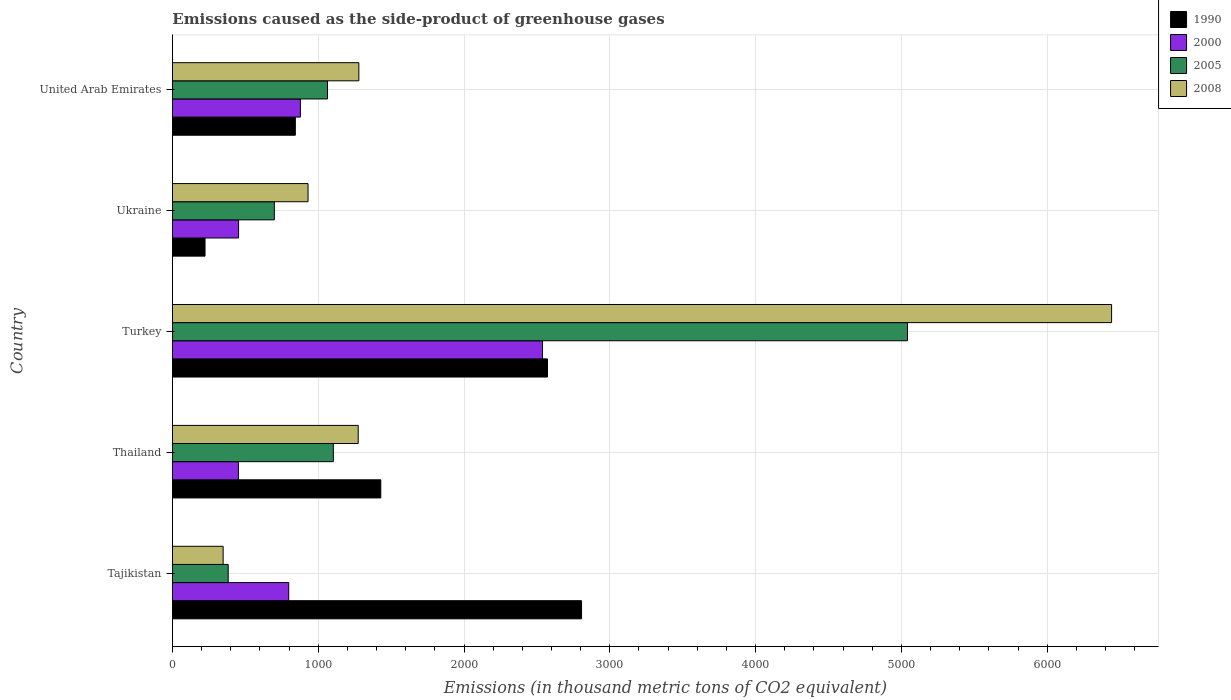How many different coloured bars are there?
Keep it short and to the point. 4. How many groups of bars are there?
Offer a terse response. 5. Are the number of bars per tick equal to the number of legend labels?
Provide a short and direct response. Yes. Are the number of bars on each tick of the Y-axis equal?
Provide a succinct answer. Yes. How many bars are there on the 3rd tick from the top?
Offer a very short reply. 4. How many bars are there on the 2nd tick from the bottom?
Make the answer very short. 4. What is the label of the 2nd group of bars from the top?
Give a very brief answer. Ukraine. What is the emissions caused as the side-product of greenhouse gases in 2005 in Turkey?
Your answer should be very brief. 5041.3. Across all countries, what is the maximum emissions caused as the side-product of greenhouse gases in 2008?
Make the answer very short. 6441. Across all countries, what is the minimum emissions caused as the side-product of greenhouse gases in 2005?
Provide a short and direct response. 383. In which country was the emissions caused as the side-product of greenhouse gases in 2008 maximum?
Give a very brief answer. Turkey. In which country was the emissions caused as the side-product of greenhouse gases in 1990 minimum?
Ensure brevity in your answer.  Ukraine. What is the total emissions caused as the side-product of greenhouse gases in 2000 in the graph?
Provide a short and direct response. 5121.9. What is the difference between the emissions caused as the side-product of greenhouse gases in 2005 in Ukraine and that in United Arab Emirates?
Offer a terse response. -364.8. What is the difference between the emissions caused as the side-product of greenhouse gases in 2008 in Tajikistan and the emissions caused as the side-product of greenhouse gases in 1990 in United Arab Emirates?
Ensure brevity in your answer.  -495.1. What is the average emissions caused as the side-product of greenhouse gases in 2005 per country?
Provide a short and direct response. 1658.32. What is the difference between the emissions caused as the side-product of greenhouse gases in 2000 and emissions caused as the side-product of greenhouse gases in 2005 in Thailand?
Ensure brevity in your answer.  -650.8. What is the ratio of the emissions caused as the side-product of greenhouse gases in 2000 in Thailand to that in Turkey?
Your answer should be compact. 0.18. Is the emissions caused as the side-product of greenhouse gases in 1990 in Turkey less than that in Ukraine?
Provide a short and direct response. No. Is the difference between the emissions caused as the side-product of greenhouse gases in 2000 in Thailand and United Arab Emirates greater than the difference between the emissions caused as the side-product of greenhouse gases in 2005 in Thailand and United Arab Emirates?
Provide a succinct answer. No. What is the difference between the highest and the second highest emissions caused as the side-product of greenhouse gases in 2005?
Give a very brief answer. 3937.4. What is the difference between the highest and the lowest emissions caused as the side-product of greenhouse gases in 2000?
Your response must be concise. 2085.4. Is the sum of the emissions caused as the side-product of greenhouse gases in 2000 in Turkey and Ukraine greater than the maximum emissions caused as the side-product of greenhouse gases in 2005 across all countries?
Your response must be concise. No. What does the 4th bar from the bottom in Thailand represents?
Give a very brief answer. 2008. Is it the case that in every country, the sum of the emissions caused as the side-product of greenhouse gases in 2005 and emissions caused as the side-product of greenhouse gases in 2008 is greater than the emissions caused as the side-product of greenhouse gases in 2000?
Provide a short and direct response. No. How many countries are there in the graph?
Your answer should be compact. 5. Are the values on the major ticks of X-axis written in scientific E-notation?
Give a very brief answer. No. Where does the legend appear in the graph?
Offer a terse response. Top right. How many legend labels are there?
Keep it short and to the point. 4. How are the legend labels stacked?
Offer a terse response. Vertical. What is the title of the graph?
Your answer should be very brief. Emissions caused as the side-product of greenhouse gases. Does "1963" appear as one of the legend labels in the graph?
Offer a very short reply. No. What is the label or title of the X-axis?
Keep it short and to the point. Emissions (in thousand metric tons of CO2 equivalent). What is the Emissions (in thousand metric tons of CO2 equivalent) of 1990 in Tajikistan?
Keep it short and to the point. 2806.1. What is the Emissions (in thousand metric tons of CO2 equivalent) in 2000 in Tajikistan?
Your response must be concise. 798. What is the Emissions (in thousand metric tons of CO2 equivalent) in 2005 in Tajikistan?
Your answer should be very brief. 383. What is the Emissions (in thousand metric tons of CO2 equivalent) in 2008 in Tajikistan?
Keep it short and to the point. 348.3. What is the Emissions (in thousand metric tons of CO2 equivalent) of 1990 in Thailand?
Keep it short and to the point. 1429.5. What is the Emissions (in thousand metric tons of CO2 equivalent) in 2000 in Thailand?
Your answer should be compact. 453.1. What is the Emissions (in thousand metric tons of CO2 equivalent) of 2005 in Thailand?
Provide a succinct answer. 1103.9. What is the Emissions (in thousand metric tons of CO2 equivalent) of 2008 in Thailand?
Offer a terse response. 1274.5. What is the Emissions (in thousand metric tons of CO2 equivalent) in 1990 in Turkey?
Your answer should be compact. 2572.7. What is the Emissions (in thousand metric tons of CO2 equivalent) in 2000 in Turkey?
Provide a succinct answer. 2538.5. What is the Emissions (in thousand metric tons of CO2 equivalent) in 2005 in Turkey?
Provide a short and direct response. 5041.3. What is the Emissions (in thousand metric tons of CO2 equivalent) in 2008 in Turkey?
Offer a very short reply. 6441. What is the Emissions (in thousand metric tons of CO2 equivalent) of 1990 in Ukraine?
Provide a succinct answer. 224.1. What is the Emissions (in thousand metric tons of CO2 equivalent) in 2000 in Ukraine?
Your response must be concise. 454.2. What is the Emissions (in thousand metric tons of CO2 equivalent) of 2005 in Ukraine?
Your answer should be compact. 699.3. What is the Emissions (in thousand metric tons of CO2 equivalent) of 2008 in Ukraine?
Your answer should be very brief. 930.6. What is the Emissions (in thousand metric tons of CO2 equivalent) in 1990 in United Arab Emirates?
Provide a succinct answer. 843.4. What is the Emissions (in thousand metric tons of CO2 equivalent) of 2000 in United Arab Emirates?
Offer a very short reply. 878.1. What is the Emissions (in thousand metric tons of CO2 equivalent) of 2005 in United Arab Emirates?
Make the answer very short. 1064.1. What is the Emissions (in thousand metric tons of CO2 equivalent) in 2008 in United Arab Emirates?
Ensure brevity in your answer.  1279. Across all countries, what is the maximum Emissions (in thousand metric tons of CO2 equivalent) of 1990?
Your response must be concise. 2806.1. Across all countries, what is the maximum Emissions (in thousand metric tons of CO2 equivalent) of 2000?
Your response must be concise. 2538.5. Across all countries, what is the maximum Emissions (in thousand metric tons of CO2 equivalent) of 2005?
Provide a short and direct response. 5041.3. Across all countries, what is the maximum Emissions (in thousand metric tons of CO2 equivalent) of 2008?
Give a very brief answer. 6441. Across all countries, what is the minimum Emissions (in thousand metric tons of CO2 equivalent) of 1990?
Make the answer very short. 224.1. Across all countries, what is the minimum Emissions (in thousand metric tons of CO2 equivalent) in 2000?
Provide a succinct answer. 453.1. Across all countries, what is the minimum Emissions (in thousand metric tons of CO2 equivalent) in 2005?
Your answer should be compact. 383. Across all countries, what is the minimum Emissions (in thousand metric tons of CO2 equivalent) of 2008?
Give a very brief answer. 348.3. What is the total Emissions (in thousand metric tons of CO2 equivalent) in 1990 in the graph?
Provide a succinct answer. 7875.8. What is the total Emissions (in thousand metric tons of CO2 equivalent) in 2000 in the graph?
Provide a succinct answer. 5121.9. What is the total Emissions (in thousand metric tons of CO2 equivalent) of 2005 in the graph?
Provide a short and direct response. 8291.6. What is the total Emissions (in thousand metric tons of CO2 equivalent) in 2008 in the graph?
Offer a very short reply. 1.03e+04. What is the difference between the Emissions (in thousand metric tons of CO2 equivalent) of 1990 in Tajikistan and that in Thailand?
Keep it short and to the point. 1376.6. What is the difference between the Emissions (in thousand metric tons of CO2 equivalent) in 2000 in Tajikistan and that in Thailand?
Offer a very short reply. 344.9. What is the difference between the Emissions (in thousand metric tons of CO2 equivalent) in 2005 in Tajikistan and that in Thailand?
Offer a very short reply. -720.9. What is the difference between the Emissions (in thousand metric tons of CO2 equivalent) in 2008 in Tajikistan and that in Thailand?
Your answer should be compact. -926.2. What is the difference between the Emissions (in thousand metric tons of CO2 equivalent) of 1990 in Tajikistan and that in Turkey?
Provide a short and direct response. 233.4. What is the difference between the Emissions (in thousand metric tons of CO2 equivalent) of 2000 in Tajikistan and that in Turkey?
Ensure brevity in your answer.  -1740.5. What is the difference between the Emissions (in thousand metric tons of CO2 equivalent) in 2005 in Tajikistan and that in Turkey?
Give a very brief answer. -4658.3. What is the difference between the Emissions (in thousand metric tons of CO2 equivalent) in 2008 in Tajikistan and that in Turkey?
Offer a terse response. -6092.7. What is the difference between the Emissions (in thousand metric tons of CO2 equivalent) in 1990 in Tajikistan and that in Ukraine?
Your answer should be compact. 2582. What is the difference between the Emissions (in thousand metric tons of CO2 equivalent) of 2000 in Tajikistan and that in Ukraine?
Offer a terse response. 343.8. What is the difference between the Emissions (in thousand metric tons of CO2 equivalent) of 2005 in Tajikistan and that in Ukraine?
Provide a succinct answer. -316.3. What is the difference between the Emissions (in thousand metric tons of CO2 equivalent) of 2008 in Tajikistan and that in Ukraine?
Your response must be concise. -582.3. What is the difference between the Emissions (in thousand metric tons of CO2 equivalent) of 1990 in Tajikistan and that in United Arab Emirates?
Keep it short and to the point. 1962.7. What is the difference between the Emissions (in thousand metric tons of CO2 equivalent) in 2000 in Tajikistan and that in United Arab Emirates?
Offer a very short reply. -80.1. What is the difference between the Emissions (in thousand metric tons of CO2 equivalent) in 2005 in Tajikistan and that in United Arab Emirates?
Provide a short and direct response. -681.1. What is the difference between the Emissions (in thousand metric tons of CO2 equivalent) of 2008 in Tajikistan and that in United Arab Emirates?
Make the answer very short. -930.7. What is the difference between the Emissions (in thousand metric tons of CO2 equivalent) in 1990 in Thailand and that in Turkey?
Provide a short and direct response. -1143.2. What is the difference between the Emissions (in thousand metric tons of CO2 equivalent) of 2000 in Thailand and that in Turkey?
Make the answer very short. -2085.4. What is the difference between the Emissions (in thousand metric tons of CO2 equivalent) of 2005 in Thailand and that in Turkey?
Offer a terse response. -3937.4. What is the difference between the Emissions (in thousand metric tons of CO2 equivalent) of 2008 in Thailand and that in Turkey?
Offer a very short reply. -5166.5. What is the difference between the Emissions (in thousand metric tons of CO2 equivalent) in 1990 in Thailand and that in Ukraine?
Provide a succinct answer. 1205.4. What is the difference between the Emissions (in thousand metric tons of CO2 equivalent) of 2005 in Thailand and that in Ukraine?
Provide a short and direct response. 404.6. What is the difference between the Emissions (in thousand metric tons of CO2 equivalent) in 2008 in Thailand and that in Ukraine?
Give a very brief answer. 343.9. What is the difference between the Emissions (in thousand metric tons of CO2 equivalent) in 1990 in Thailand and that in United Arab Emirates?
Your answer should be very brief. 586.1. What is the difference between the Emissions (in thousand metric tons of CO2 equivalent) of 2000 in Thailand and that in United Arab Emirates?
Offer a terse response. -425. What is the difference between the Emissions (in thousand metric tons of CO2 equivalent) of 2005 in Thailand and that in United Arab Emirates?
Your response must be concise. 39.8. What is the difference between the Emissions (in thousand metric tons of CO2 equivalent) of 2008 in Thailand and that in United Arab Emirates?
Your answer should be compact. -4.5. What is the difference between the Emissions (in thousand metric tons of CO2 equivalent) in 1990 in Turkey and that in Ukraine?
Ensure brevity in your answer.  2348.6. What is the difference between the Emissions (in thousand metric tons of CO2 equivalent) of 2000 in Turkey and that in Ukraine?
Your response must be concise. 2084.3. What is the difference between the Emissions (in thousand metric tons of CO2 equivalent) of 2005 in Turkey and that in Ukraine?
Your response must be concise. 4342. What is the difference between the Emissions (in thousand metric tons of CO2 equivalent) in 2008 in Turkey and that in Ukraine?
Provide a succinct answer. 5510.4. What is the difference between the Emissions (in thousand metric tons of CO2 equivalent) of 1990 in Turkey and that in United Arab Emirates?
Keep it short and to the point. 1729.3. What is the difference between the Emissions (in thousand metric tons of CO2 equivalent) of 2000 in Turkey and that in United Arab Emirates?
Give a very brief answer. 1660.4. What is the difference between the Emissions (in thousand metric tons of CO2 equivalent) in 2005 in Turkey and that in United Arab Emirates?
Your answer should be compact. 3977.2. What is the difference between the Emissions (in thousand metric tons of CO2 equivalent) in 2008 in Turkey and that in United Arab Emirates?
Make the answer very short. 5162. What is the difference between the Emissions (in thousand metric tons of CO2 equivalent) of 1990 in Ukraine and that in United Arab Emirates?
Provide a succinct answer. -619.3. What is the difference between the Emissions (in thousand metric tons of CO2 equivalent) of 2000 in Ukraine and that in United Arab Emirates?
Provide a short and direct response. -423.9. What is the difference between the Emissions (in thousand metric tons of CO2 equivalent) of 2005 in Ukraine and that in United Arab Emirates?
Provide a succinct answer. -364.8. What is the difference between the Emissions (in thousand metric tons of CO2 equivalent) in 2008 in Ukraine and that in United Arab Emirates?
Provide a short and direct response. -348.4. What is the difference between the Emissions (in thousand metric tons of CO2 equivalent) in 1990 in Tajikistan and the Emissions (in thousand metric tons of CO2 equivalent) in 2000 in Thailand?
Ensure brevity in your answer.  2353. What is the difference between the Emissions (in thousand metric tons of CO2 equivalent) of 1990 in Tajikistan and the Emissions (in thousand metric tons of CO2 equivalent) of 2005 in Thailand?
Provide a succinct answer. 1702.2. What is the difference between the Emissions (in thousand metric tons of CO2 equivalent) of 1990 in Tajikistan and the Emissions (in thousand metric tons of CO2 equivalent) of 2008 in Thailand?
Your response must be concise. 1531.6. What is the difference between the Emissions (in thousand metric tons of CO2 equivalent) of 2000 in Tajikistan and the Emissions (in thousand metric tons of CO2 equivalent) of 2005 in Thailand?
Your answer should be very brief. -305.9. What is the difference between the Emissions (in thousand metric tons of CO2 equivalent) in 2000 in Tajikistan and the Emissions (in thousand metric tons of CO2 equivalent) in 2008 in Thailand?
Offer a terse response. -476.5. What is the difference between the Emissions (in thousand metric tons of CO2 equivalent) of 2005 in Tajikistan and the Emissions (in thousand metric tons of CO2 equivalent) of 2008 in Thailand?
Offer a very short reply. -891.5. What is the difference between the Emissions (in thousand metric tons of CO2 equivalent) of 1990 in Tajikistan and the Emissions (in thousand metric tons of CO2 equivalent) of 2000 in Turkey?
Offer a terse response. 267.6. What is the difference between the Emissions (in thousand metric tons of CO2 equivalent) of 1990 in Tajikistan and the Emissions (in thousand metric tons of CO2 equivalent) of 2005 in Turkey?
Your answer should be compact. -2235.2. What is the difference between the Emissions (in thousand metric tons of CO2 equivalent) of 1990 in Tajikistan and the Emissions (in thousand metric tons of CO2 equivalent) of 2008 in Turkey?
Offer a very short reply. -3634.9. What is the difference between the Emissions (in thousand metric tons of CO2 equivalent) of 2000 in Tajikistan and the Emissions (in thousand metric tons of CO2 equivalent) of 2005 in Turkey?
Offer a terse response. -4243.3. What is the difference between the Emissions (in thousand metric tons of CO2 equivalent) in 2000 in Tajikistan and the Emissions (in thousand metric tons of CO2 equivalent) in 2008 in Turkey?
Your response must be concise. -5643. What is the difference between the Emissions (in thousand metric tons of CO2 equivalent) in 2005 in Tajikistan and the Emissions (in thousand metric tons of CO2 equivalent) in 2008 in Turkey?
Give a very brief answer. -6058. What is the difference between the Emissions (in thousand metric tons of CO2 equivalent) in 1990 in Tajikistan and the Emissions (in thousand metric tons of CO2 equivalent) in 2000 in Ukraine?
Your response must be concise. 2351.9. What is the difference between the Emissions (in thousand metric tons of CO2 equivalent) of 1990 in Tajikistan and the Emissions (in thousand metric tons of CO2 equivalent) of 2005 in Ukraine?
Keep it short and to the point. 2106.8. What is the difference between the Emissions (in thousand metric tons of CO2 equivalent) of 1990 in Tajikistan and the Emissions (in thousand metric tons of CO2 equivalent) of 2008 in Ukraine?
Give a very brief answer. 1875.5. What is the difference between the Emissions (in thousand metric tons of CO2 equivalent) of 2000 in Tajikistan and the Emissions (in thousand metric tons of CO2 equivalent) of 2005 in Ukraine?
Offer a terse response. 98.7. What is the difference between the Emissions (in thousand metric tons of CO2 equivalent) of 2000 in Tajikistan and the Emissions (in thousand metric tons of CO2 equivalent) of 2008 in Ukraine?
Provide a succinct answer. -132.6. What is the difference between the Emissions (in thousand metric tons of CO2 equivalent) of 2005 in Tajikistan and the Emissions (in thousand metric tons of CO2 equivalent) of 2008 in Ukraine?
Your answer should be compact. -547.6. What is the difference between the Emissions (in thousand metric tons of CO2 equivalent) in 1990 in Tajikistan and the Emissions (in thousand metric tons of CO2 equivalent) in 2000 in United Arab Emirates?
Give a very brief answer. 1928. What is the difference between the Emissions (in thousand metric tons of CO2 equivalent) in 1990 in Tajikistan and the Emissions (in thousand metric tons of CO2 equivalent) in 2005 in United Arab Emirates?
Provide a succinct answer. 1742. What is the difference between the Emissions (in thousand metric tons of CO2 equivalent) of 1990 in Tajikistan and the Emissions (in thousand metric tons of CO2 equivalent) of 2008 in United Arab Emirates?
Make the answer very short. 1527.1. What is the difference between the Emissions (in thousand metric tons of CO2 equivalent) in 2000 in Tajikistan and the Emissions (in thousand metric tons of CO2 equivalent) in 2005 in United Arab Emirates?
Your answer should be compact. -266.1. What is the difference between the Emissions (in thousand metric tons of CO2 equivalent) of 2000 in Tajikistan and the Emissions (in thousand metric tons of CO2 equivalent) of 2008 in United Arab Emirates?
Your response must be concise. -481. What is the difference between the Emissions (in thousand metric tons of CO2 equivalent) of 2005 in Tajikistan and the Emissions (in thousand metric tons of CO2 equivalent) of 2008 in United Arab Emirates?
Keep it short and to the point. -896. What is the difference between the Emissions (in thousand metric tons of CO2 equivalent) in 1990 in Thailand and the Emissions (in thousand metric tons of CO2 equivalent) in 2000 in Turkey?
Provide a short and direct response. -1109. What is the difference between the Emissions (in thousand metric tons of CO2 equivalent) in 1990 in Thailand and the Emissions (in thousand metric tons of CO2 equivalent) in 2005 in Turkey?
Offer a very short reply. -3611.8. What is the difference between the Emissions (in thousand metric tons of CO2 equivalent) in 1990 in Thailand and the Emissions (in thousand metric tons of CO2 equivalent) in 2008 in Turkey?
Provide a succinct answer. -5011.5. What is the difference between the Emissions (in thousand metric tons of CO2 equivalent) in 2000 in Thailand and the Emissions (in thousand metric tons of CO2 equivalent) in 2005 in Turkey?
Your answer should be compact. -4588.2. What is the difference between the Emissions (in thousand metric tons of CO2 equivalent) of 2000 in Thailand and the Emissions (in thousand metric tons of CO2 equivalent) of 2008 in Turkey?
Your answer should be very brief. -5987.9. What is the difference between the Emissions (in thousand metric tons of CO2 equivalent) in 2005 in Thailand and the Emissions (in thousand metric tons of CO2 equivalent) in 2008 in Turkey?
Your answer should be compact. -5337.1. What is the difference between the Emissions (in thousand metric tons of CO2 equivalent) of 1990 in Thailand and the Emissions (in thousand metric tons of CO2 equivalent) of 2000 in Ukraine?
Make the answer very short. 975.3. What is the difference between the Emissions (in thousand metric tons of CO2 equivalent) of 1990 in Thailand and the Emissions (in thousand metric tons of CO2 equivalent) of 2005 in Ukraine?
Ensure brevity in your answer.  730.2. What is the difference between the Emissions (in thousand metric tons of CO2 equivalent) of 1990 in Thailand and the Emissions (in thousand metric tons of CO2 equivalent) of 2008 in Ukraine?
Your response must be concise. 498.9. What is the difference between the Emissions (in thousand metric tons of CO2 equivalent) in 2000 in Thailand and the Emissions (in thousand metric tons of CO2 equivalent) in 2005 in Ukraine?
Your answer should be compact. -246.2. What is the difference between the Emissions (in thousand metric tons of CO2 equivalent) of 2000 in Thailand and the Emissions (in thousand metric tons of CO2 equivalent) of 2008 in Ukraine?
Offer a very short reply. -477.5. What is the difference between the Emissions (in thousand metric tons of CO2 equivalent) in 2005 in Thailand and the Emissions (in thousand metric tons of CO2 equivalent) in 2008 in Ukraine?
Make the answer very short. 173.3. What is the difference between the Emissions (in thousand metric tons of CO2 equivalent) of 1990 in Thailand and the Emissions (in thousand metric tons of CO2 equivalent) of 2000 in United Arab Emirates?
Give a very brief answer. 551.4. What is the difference between the Emissions (in thousand metric tons of CO2 equivalent) of 1990 in Thailand and the Emissions (in thousand metric tons of CO2 equivalent) of 2005 in United Arab Emirates?
Your answer should be very brief. 365.4. What is the difference between the Emissions (in thousand metric tons of CO2 equivalent) of 1990 in Thailand and the Emissions (in thousand metric tons of CO2 equivalent) of 2008 in United Arab Emirates?
Give a very brief answer. 150.5. What is the difference between the Emissions (in thousand metric tons of CO2 equivalent) of 2000 in Thailand and the Emissions (in thousand metric tons of CO2 equivalent) of 2005 in United Arab Emirates?
Make the answer very short. -611. What is the difference between the Emissions (in thousand metric tons of CO2 equivalent) of 2000 in Thailand and the Emissions (in thousand metric tons of CO2 equivalent) of 2008 in United Arab Emirates?
Provide a succinct answer. -825.9. What is the difference between the Emissions (in thousand metric tons of CO2 equivalent) in 2005 in Thailand and the Emissions (in thousand metric tons of CO2 equivalent) in 2008 in United Arab Emirates?
Your answer should be very brief. -175.1. What is the difference between the Emissions (in thousand metric tons of CO2 equivalent) in 1990 in Turkey and the Emissions (in thousand metric tons of CO2 equivalent) in 2000 in Ukraine?
Ensure brevity in your answer.  2118.5. What is the difference between the Emissions (in thousand metric tons of CO2 equivalent) in 1990 in Turkey and the Emissions (in thousand metric tons of CO2 equivalent) in 2005 in Ukraine?
Provide a succinct answer. 1873.4. What is the difference between the Emissions (in thousand metric tons of CO2 equivalent) of 1990 in Turkey and the Emissions (in thousand metric tons of CO2 equivalent) of 2008 in Ukraine?
Provide a succinct answer. 1642.1. What is the difference between the Emissions (in thousand metric tons of CO2 equivalent) in 2000 in Turkey and the Emissions (in thousand metric tons of CO2 equivalent) in 2005 in Ukraine?
Your response must be concise. 1839.2. What is the difference between the Emissions (in thousand metric tons of CO2 equivalent) of 2000 in Turkey and the Emissions (in thousand metric tons of CO2 equivalent) of 2008 in Ukraine?
Give a very brief answer. 1607.9. What is the difference between the Emissions (in thousand metric tons of CO2 equivalent) in 2005 in Turkey and the Emissions (in thousand metric tons of CO2 equivalent) in 2008 in Ukraine?
Your answer should be compact. 4110.7. What is the difference between the Emissions (in thousand metric tons of CO2 equivalent) of 1990 in Turkey and the Emissions (in thousand metric tons of CO2 equivalent) of 2000 in United Arab Emirates?
Your answer should be very brief. 1694.6. What is the difference between the Emissions (in thousand metric tons of CO2 equivalent) in 1990 in Turkey and the Emissions (in thousand metric tons of CO2 equivalent) in 2005 in United Arab Emirates?
Offer a terse response. 1508.6. What is the difference between the Emissions (in thousand metric tons of CO2 equivalent) of 1990 in Turkey and the Emissions (in thousand metric tons of CO2 equivalent) of 2008 in United Arab Emirates?
Offer a very short reply. 1293.7. What is the difference between the Emissions (in thousand metric tons of CO2 equivalent) of 2000 in Turkey and the Emissions (in thousand metric tons of CO2 equivalent) of 2005 in United Arab Emirates?
Ensure brevity in your answer.  1474.4. What is the difference between the Emissions (in thousand metric tons of CO2 equivalent) in 2000 in Turkey and the Emissions (in thousand metric tons of CO2 equivalent) in 2008 in United Arab Emirates?
Keep it short and to the point. 1259.5. What is the difference between the Emissions (in thousand metric tons of CO2 equivalent) of 2005 in Turkey and the Emissions (in thousand metric tons of CO2 equivalent) of 2008 in United Arab Emirates?
Make the answer very short. 3762.3. What is the difference between the Emissions (in thousand metric tons of CO2 equivalent) in 1990 in Ukraine and the Emissions (in thousand metric tons of CO2 equivalent) in 2000 in United Arab Emirates?
Provide a succinct answer. -654. What is the difference between the Emissions (in thousand metric tons of CO2 equivalent) in 1990 in Ukraine and the Emissions (in thousand metric tons of CO2 equivalent) in 2005 in United Arab Emirates?
Keep it short and to the point. -840. What is the difference between the Emissions (in thousand metric tons of CO2 equivalent) in 1990 in Ukraine and the Emissions (in thousand metric tons of CO2 equivalent) in 2008 in United Arab Emirates?
Your answer should be very brief. -1054.9. What is the difference between the Emissions (in thousand metric tons of CO2 equivalent) of 2000 in Ukraine and the Emissions (in thousand metric tons of CO2 equivalent) of 2005 in United Arab Emirates?
Your response must be concise. -609.9. What is the difference between the Emissions (in thousand metric tons of CO2 equivalent) of 2000 in Ukraine and the Emissions (in thousand metric tons of CO2 equivalent) of 2008 in United Arab Emirates?
Provide a succinct answer. -824.8. What is the difference between the Emissions (in thousand metric tons of CO2 equivalent) of 2005 in Ukraine and the Emissions (in thousand metric tons of CO2 equivalent) of 2008 in United Arab Emirates?
Your answer should be compact. -579.7. What is the average Emissions (in thousand metric tons of CO2 equivalent) of 1990 per country?
Give a very brief answer. 1575.16. What is the average Emissions (in thousand metric tons of CO2 equivalent) of 2000 per country?
Offer a very short reply. 1024.38. What is the average Emissions (in thousand metric tons of CO2 equivalent) in 2005 per country?
Your answer should be compact. 1658.32. What is the average Emissions (in thousand metric tons of CO2 equivalent) in 2008 per country?
Make the answer very short. 2054.68. What is the difference between the Emissions (in thousand metric tons of CO2 equivalent) in 1990 and Emissions (in thousand metric tons of CO2 equivalent) in 2000 in Tajikistan?
Keep it short and to the point. 2008.1. What is the difference between the Emissions (in thousand metric tons of CO2 equivalent) of 1990 and Emissions (in thousand metric tons of CO2 equivalent) of 2005 in Tajikistan?
Make the answer very short. 2423.1. What is the difference between the Emissions (in thousand metric tons of CO2 equivalent) in 1990 and Emissions (in thousand metric tons of CO2 equivalent) in 2008 in Tajikistan?
Provide a succinct answer. 2457.8. What is the difference between the Emissions (in thousand metric tons of CO2 equivalent) of 2000 and Emissions (in thousand metric tons of CO2 equivalent) of 2005 in Tajikistan?
Provide a succinct answer. 415. What is the difference between the Emissions (in thousand metric tons of CO2 equivalent) of 2000 and Emissions (in thousand metric tons of CO2 equivalent) of 2008 in Tajikistan?
Make the answer very short. 449.7. What is the difference between the Emissions (in thousand metric tons of CO2 equivalent) of 2005 and Emissions (in thousand metric tons of CO2 equivalent) of 2008 in Tajikistan?
Make the answer very short. 34.7. What is the difference between the Emissions (in thousand metric tons of CO2 equivalent) in 1990 and Emissions (in thousand metric tons of CO2 equivalent) in 2000 in Thailand?
Offer a terse response. 976.4. What is the difference between the Emissions (in thousand metric tons of CO2 equivalent) in 1990 and Emissions (in thousand metric tons of CO2 equivalent) in 2005 in Thailand?
Make the answer very short. 325.6. What is the difference between the Emissions (in thousand metric tons of CO2 equivalent) of 1990 and Emissions (in thousand metric tons of CO2 equivalent) of 2008 in Thailand?
Give a very brief answer. 155. What is the difference between the Emissions (in thousand metric tons of CO2 equivalent) in 2000 and Emissions (in thousand metric tons of CO2 equivalent) in 2005 in Thailand?
Provide a succinct answer. -650.8. What is the difference between the Emissions (in thousand metric tons of CO2 equivalent) in 2000 and Emissions (in thousand metric tons of CO2 equivalent) in 2008 in Thailand?
Provide a succinct answer. -821.4. What is the difference between the Emissions (in thousand metric tons of CO2 equivalent) of 2005 and Emissions (in thousand metric tons of CO2 equivalent) of 2008 in Thailand?
Make the answer very short. -170.6. What is the difference between the Emissions (in thousand metric tons of CO2 equivalent) of 1990 and Emissions (in thousand metric tons of CO2 equivalent) of 2000 in Turkey?
Give a very brief answer. 34.2. What is the difference between the Emissions (in thousand metric tons of CO2 equivalent) in 1990 and Emissions (in thousand metric tons of CO2 equivalent) in 2005 in Turkey?
Your answer should be compact. -2468.6. What is the difference between the Emissions (in thousand metric tons of CO2 equivalent) in 1990 and Emissions (in thousand metric tons of CO2 equivalent) in 2008 in Turkey?
Provide a short and direct response. -3868.3. What is the difference between the Emissions (in thousand metric tons of CO2 equivalent) in 2000 and Emissions (in thousand metric tons of CO2 equivalent) in 2005 in Turkey?
Your answer should be compact. -2502.8. What is the difference between the Emissions (in thousand metric tons of CO2 equivalent) of 2000 and Emissions (in thousand metric tons of CO2 equivalent) of 2008 in Turkey?
Make the answer very short. -3902.5. What is the difference between the Emissions (in thousand metric tons of CO2 equivalent) of 2005 and Emissions (in thousand metric tons of CO2 equivalent) of 2008 in Turkey?
Offer a terse response. -1399.7. What is the difference between the Emissions (in thousand metric tons of CO2 equivalent) of 1990 and Emissions (in thousand metric tons of CO2 equivalent) of 2000 in Ukraine?
Your response must be concise. -230.1. What is the difference between the Emissions (in thousand metric tons of CO2 equivalent) in 1990 and Emissions (in thousand metric tons of CO2 equivalent) in 2005 in Ukraine?
Your answer should be compact. -475.2. What is the difference between the Emissions (in thousand metric tons of CO2 equivalent) in 1990 and Emissions (in thousand metric tons of CO2 equivalent) in 2008 in Ukraine?
Keep it short and to the point. -706.5. What is the difference between the Emissions (in thousand metric tons of CO2 equivalent) of 2000 and Emissions (in thousand metric tons of CO2 equivalent) of 2005 in Ukraine?
Your response must be concise. -245.1. What is the difference between the Emissions (in thousand metric tons of CO2 equivalent) in 2000 and Emissions (in thousand metric tons of CO2 equivalent) in 2008 in Ukraine?
Keep it short and to the point. -476.4. What is the difference between the Emissions (in thousand metric tons of CO2 equivalent) in 2005 and Emissions (in thousand metric tons of CO2 equivalent) in 2008 in Ukraine?
Make the answer very short. -231.3. What is the difference between the Emissions (in thousand metric tons of CO2 equivalent) in 1990 and Emissions (in thousand metric tons of CO2 equivalent) in 2000 in United Arab Emirates?
Ensure brevity in your answer.  -34.7. What is the difference between the Emissions (in thousand metric tons of CO2 equivalent) in 1990 and Emissions (in thousand metric tons of CO2 equivalent) in 2005 in United Arab Emirates?
Provide a succinct answer. -220.7. What is the difference between the Emissions (in thousand metric tons of CO2 equivalent) in 1990 and Emissions (in thousand metric tons of CO2 equivalent) in 2008 in United Arab Emirates?
Offer a very short reply. -435.6. What is the difference between the Emissions (in thousand metric tons of CO2 equivalent) of 2000 and Emissions (in thousand metric tons of CO2 equivalent) of 2005 in United Arab Emirates?
Your answer should be very brief. -186. What is the difference between the Emissions (in thousand metric tons of CO2 equivalent) in 2000 and Emissions (in thousand metric tons of CO2 equivalent) in 2008 in United Arab Emirates?
Offer a very short reply. -400.9. What is the difference between the Emissions (in thousand metric tons of CO2 equivalent) in 2005 and Emissions (in thousand metric tons of CO2 equivalent) in 2008 in United Arab Emirates?
Provide a short and direct response. -214.9. What is the ratio of the Emissions (in thousand metric tons of CO2 equivalent) of 1990 in Tajikistan to that in Thailand?
Your response must be concise. 1.96. What is the ratio of the Emissions (in thousand metric tons of CO2 equivalent) in 2000 in Tajikistan to that in Thailand?
Your response must be concise. 1.76. What is the ratio of the Emissions (in thousand metric tons of CO2 equivalent) of 2005 in Tajikistan to that in Thailand?
Provide a succinct answer. 0.35. What is the ratio of the Emissions (in thousand metric tons of CO2 equivalent) of 2008 in Tajikistan to that in Thailand?
Your response must be concise. 0.27. What is the ratio of the Emissions (in thousand metric tons of CO2 equivalent) in 1990 in Tajikistan to that in Turkey?
Give a very brief answer. 1.09. What is the ratio of the Emissions (in thousand metric tons of CO2 equivalent) in 2000 in Tajikistan to that in Turkey?
Ensure brevity in your answer.  0.31. What is the ratio of the Emissions (in thousand metric tons of CO2 equivalent) in 2005 in Tajikistan to that in Turkey?
Keep it short and to the point. 0.08. What is the ratio of the Emissions (in thousand metric tons of CO2 equivalent) of 2008 in Tajikistan to that in Turkey?
Provide a short and direct response. 0.05. What is the ratio of the Emissions (in thousand metric tons of CO2 equivalent) in 1990 in Tajikistan to that in Ukraine?
Provide a succinct answer. 12.52. What is the ratio of the Emissions (in thousand metric tons of CO2 equivalent) of 2000 in Tajikistan to that in Ukraine?
Your response must be concise. 1.76. What is the ratio of the Emissions (in thousand metric tons of CO2 equivalent) of 2005 in Tajikistan to that in Ukraine?
Your answer should be compact. 0.55. What is the ratio of the Emissions (in thousand metric tons of CO2 equivalent) of 2008 in Tajikistan to that in Ukraine?
Your answer should be compact. 0.37. What is the ratio of the Emissions (in thousand metric tons of CO2 equivalent) in 1990 in Tajikistan to that in United Arab Emirates?
Keep it short and to the point. 3.33. What is the ratio of the Emissions (in thousand metric tons of CO2 equivalent) of 2000 in Tajikistan to that in United Arab Emirates?
Make the answer very short. 0.91. What is the ratio of the Emissions (in thousand metric tons of CO2 equivalent) of 2005 in Tajikistan to that in United Arab Emirates?
Your answer should be very brief. 0.36. What is the ratio of the Emissions (in thousand metric tons of CO2 equivalent) of 2008 in Tajikistan to that in United Arab Emirates?
Your answer should be very brief. 0.27. What is the ratio of the Emissions (in thousand metric tons of CO2 equivalent) in 1990 in Thailand to that in Turkey?
Provide a succinct answer. 0.56. What is the ratio of the Emissions (in thousand metric tons of CO2 equivalent) of 2000 in Thailand to that in Turkey?
Your answer should be very brief. 0.18. What is the ratio of the Emissions (in thousand metric tons of CO2 equivalent) in 2005 in Thailand to that in Turkey?
Offer a terse response. 0.22. What is the ratio of the Emissions (in thousand metric tons of CO2 equivalent) in 2008 in Thailand to that in Turkey?
Ensure brevity in your answer.  0.2. What is the ratio of the Emissions (in thousand metric tons of CO2 equivalent) of 1990 in Thailand to that in Ukraine?
Offer a very short reply. 6.38. What is the ratio of the Emissions (in thousand metric tons of CO2 equivalent) in 2000 in Thailand to that in Ukraine?
Your response must be concise. 1. What is the ratio of the Emissions (in thousand metric tons of CO2 equivalent) of 2005 in Thailand to that in Ukraine?
Give a very brief answer. 1.58. What is the ratio of the Emissions (in thousand metric tons of CO2 equivalent) of 2008 in Thailand to that in Ukraine?
Provide a succinct answer. 1.37. What is the ratio of the Emissions (in thousand metric tons of CO2 equivalent) of 1990 in Thailand to that in United Arab Emirates?
Offer a terse response. 1.69. What is the ratio of the Emissions (in thousand metric tons of CO2 equivalent) in 2000 in Thailand to that in United Arab Emirates?
Offer a very short reply. 0.52. What is the ratio of the Emissions (in thousand metric tons of CO2 equivalent) in 2005 in Thailand to that in United Arab Emirates?
Your response must be concise. 1.04. What is the ratio of the Emissions (in thousand metric tons of CO2 equivalent) of 1990 in Turkey to that in Ukraine?
Offer a terse response. 11.48. What is the ratio of the Emissions (in thousand metric tons of CO2 equivalent) of 2000 in Turkey to that in Ukraine?
Offer a very short reply. 5.59. What is the ratio of the Emissions (in thousand metric tons of CO2 equivalent) of 2005 in Turkey to that in Ukraine?
Offer a very short reply. 7.21. What is the ratio of the Emissions (in thousand metric tons of CO2 equivalent) in 2008 in Turkey to that in Ukraine?
Keep it short and to the point. 6.92. What is the ratio of the Emissions (in thousand metric tons of CO2 equivalent) of 1990 in Turkey to that in United Arab Emirates?
Your answer should be compact. 3.05. What is the ratio of the Emissions (in thousand metric tons of CO2 equivalent) in 2000 in Turkey to that in United Arab Emirates?
Offer a very short reply. 2.89. What is the ratio of the Emissions (in thousand metric tons of CO2 equivalent) in 2005 in Turkey to that in United Arab Emirates?
Your answer should be compact. 4.74. What is the ratio of the Emissions (in thousand metric tons of CO2 equivalent) in 2008 in Turkey to that in United Arab Emirates?
Offer a terse response. 5.04. What is the ratio of the Emissions (in thousand metric tons of CO2 equivalent) of 1990 in Ukraine to that in United Arab Emirates?
Your response must be concise. 0.27. What is the ratio of the Emissions (in thousand metric tons of CO2 equivalent) of 2000 in Ukraine to that in United Arab Emirates?
Provide a short and direct response. 0.52. What is the ratio of the Emissions (in thousand metric tons of CO2 equivalent) in 2005 in Ukraine to that in United Arab Emirates?
Keep it short and to the point. 0.66. What is the ratio of the Emissions (in thousand metric tons of CO2 equivalent) of 2008 in Ukraine to that in United Arab Emirates?
Provide a succinct answer. 0.73. What is the difference between the highest and the second highest Emissions (in thousand metric tons of CO2 equivalent) of 1990?
Your answer should be compact. 233.4. What is the difference between the highest and the second highest Emissions (in thousand metric tons of CO2 equivalent) of 2000?
Your answer should be compact. 1660.4. What is the difference between the highest and the second highest Emissions (in thousand metric tons of CO2 equivalent) of 2005?
Your answer should be compact. 3937.4. What is the difference between the highest and the second highest Emissions (in thousand metric tons of CO2 equivalent) in 2008?
Make the answer very short. 5162. What is the difference between the highest and the lowest Emissions (in thousand metric tons of CO2 equivalent) of 1990?
Provide a succinct answer. 2582. What is the difference between the highest and the lowest Emissions (in thousand metric tons of CO2 equivalent) of 2000?
Keep it short and to the point. 2085.4. What is the difference between the highest and the lowest Emissions (in thousand metric tons of CO2 equivalent) of 2005?
Offer a terse response. 4658.3. What is the difference between the highest and the lowest Emissions (in thousand metric tons of CO2 equivalent) of 2008?
Make the answer very short. 6092.7. 